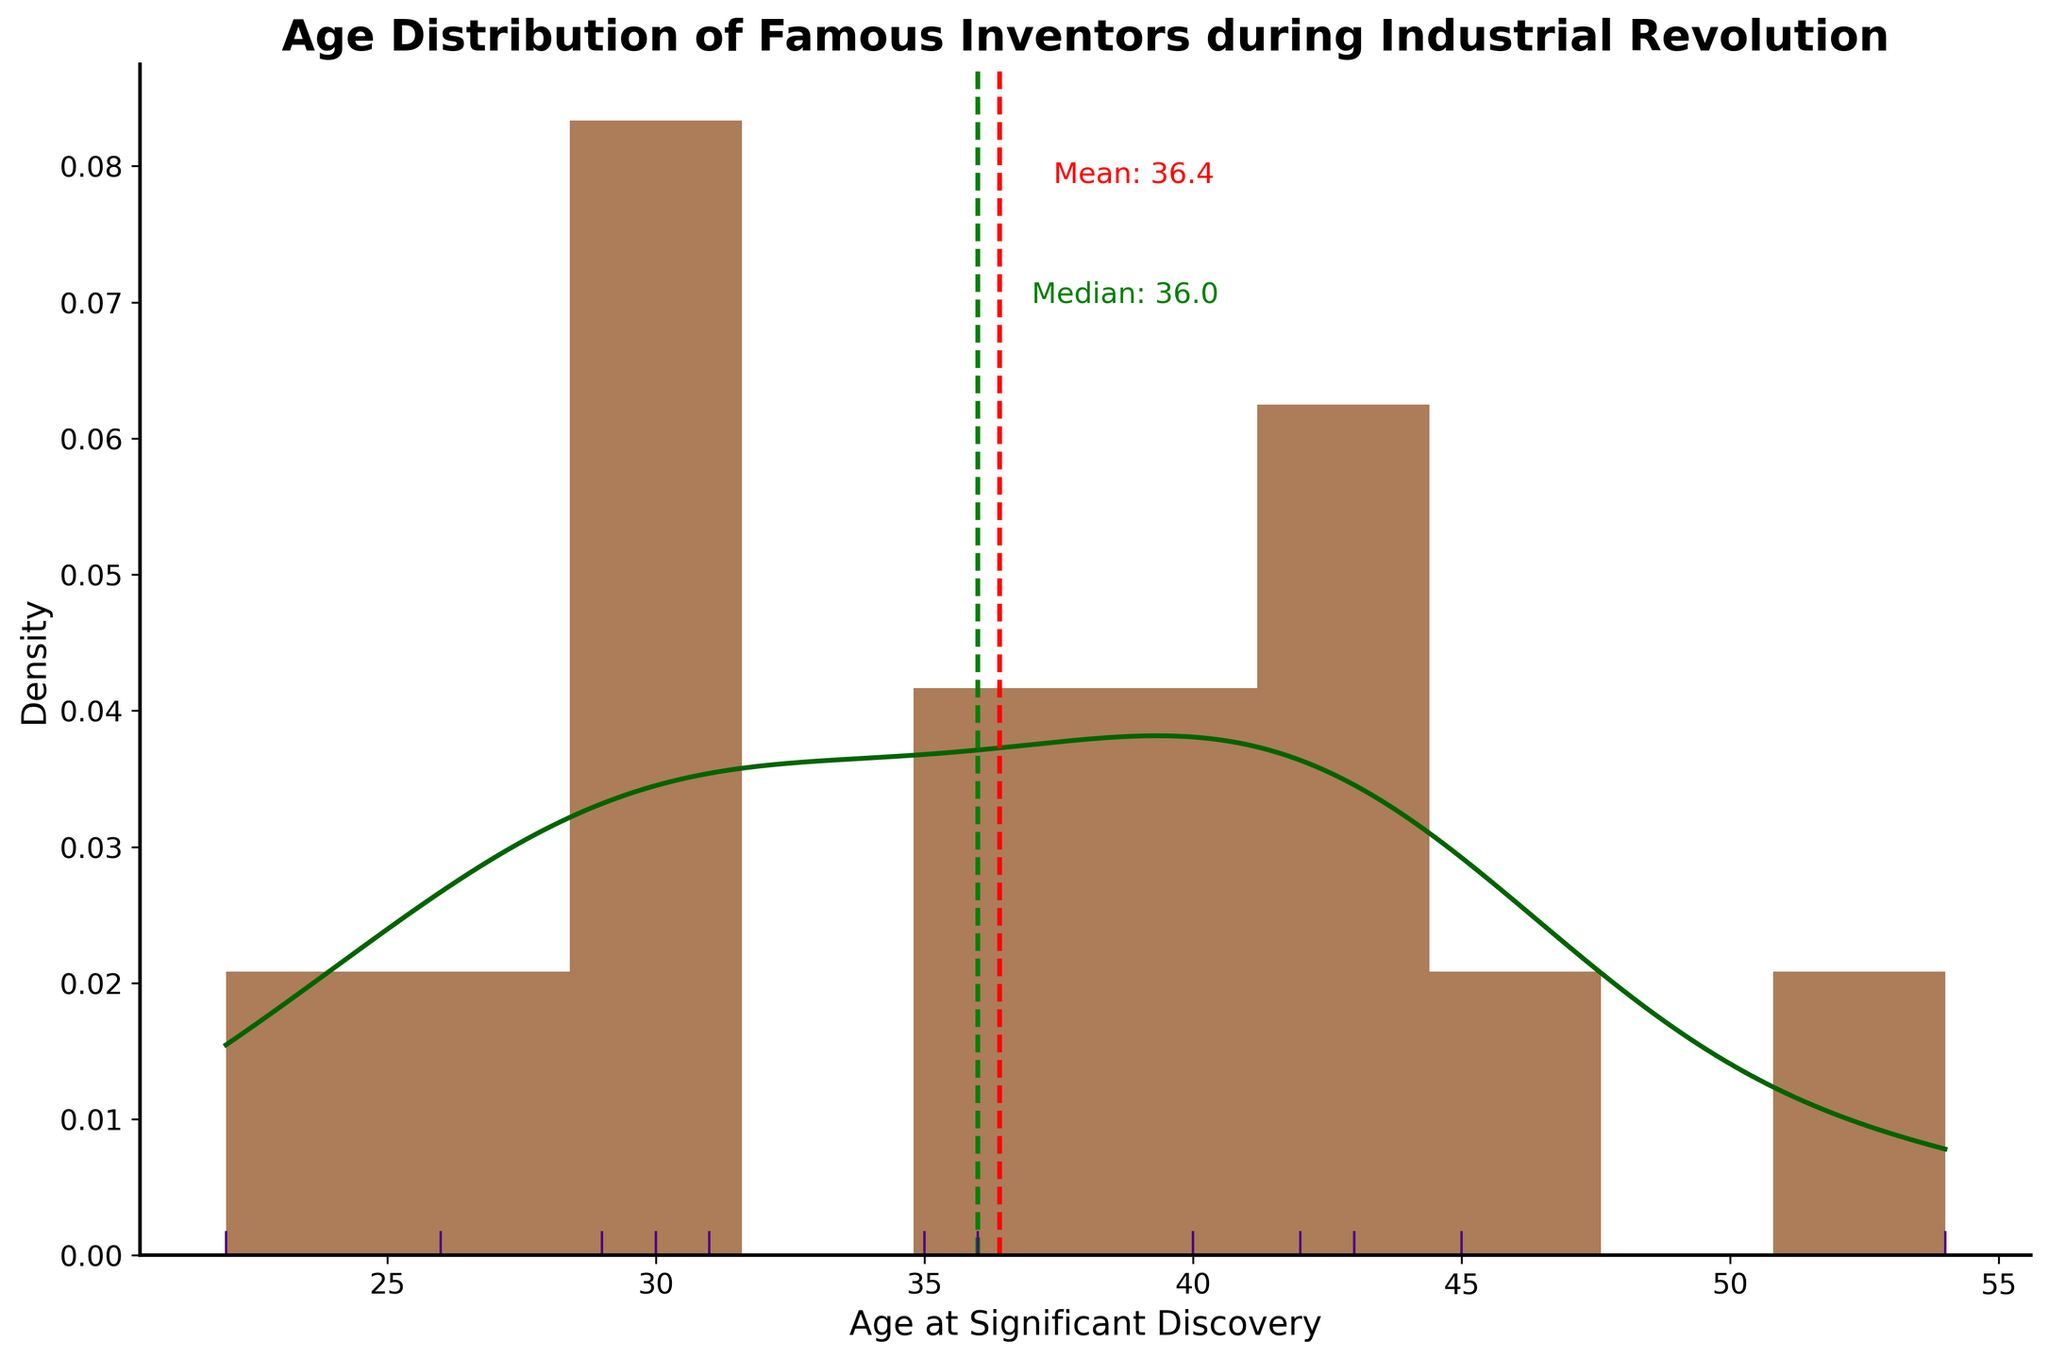what's the title of the figure? The title of a figure is usually displayed at the top and describes the content of the figure. By reading the title at the top, we can identify that it is "Age Distribution of Famous Inventors during Industrial Revolution".
Answer: Age Distribution of Famous Inventors during Industrial Revolution what is plotted on the x-axis? The x-axis of a plot is typically labeled to indicate what variable is being represented. In this figure, the x-axis is labeled "Age at Significant Discovery".
Answer: Age at Significant Discovery what is plotted on the y-axis? The y-axis of a plot is typically labeled to indicate the variable it represents. Here, the y-axis is labeled "Density", indicating that the figure shows a probability density.
Answer: Density Which color represents the histogram bars? The histogram bars are color-coded to make it easier to differentiate between elements in the plot. In this plot, the histogram bars are brown.
Answer: brown What are the vertical dashed lines on the plot, and what do they represent? Vertical dashed lines are used to mark specific values on the plot. In this figure, the red dashed line represents the mean age, and the green dashed line represents the median age at which discoveries were made.
Answer: mean (red) and median (green) What is the mean age at which significant discoveries were made? The mean age is marked by a red dashed line and is also annotated on the plot. By looking at the annotation next to the red line, we find the mean age is indicated as 35.1.
Answer: 35.1 What is the median age at which significant discoveries were made? The median age is marked by a green dashed line and is also annotated on the plot. By examining the annotation next to the green line, we can see the median age is given as 35.0.
Answer: 35.0 How many inventors made their significant discoveries before the age of 30? To determine the number of inventors who made their discoveries before age 30, we look at the histogram bars to the left of age 30 on the x-axis. The number of inventors can be counted from the rug plot marks or deduced from the height of the corresponding histogram bars. Here, we see markers at ages 22, 26, 29, and one bar below age 30. Thus, there are 4 inventors.
Answer: 4 Is the peak of the KDE curve higher or lower than the highest histogram bar? To compare the KDE peak and the highest histogram bar, observe the heights depicted in the plot. The KDE forms a smooth curve often above or below the histogram bars. Here, the peak of the KDE curve appears higher than the highest histogram bar.
Answer: higher What age range is the most frequent for significant discoveries based on the histogram? The most frequent age range can be identified by locating the tallest histogram bar. From the plot, the tallest bar lies between the ages of approximately 30 to 35, indicating it as the most frequent age range for significant discoveries.
Answer: 30 to 35 